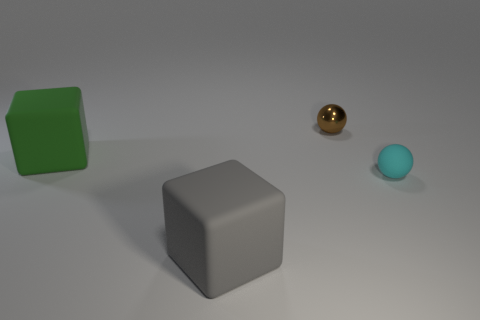Subtract all yellow spheres. Subtract all yellow cubes. How many spheres are left? 2 Add 4 large cyan objects. How many objects exist? 8 Subtract 1 brown balls. How many objects are left? 3 Subtract all purple metallic cylinders. Subtract all rubber balls. How many objects are left? 3 Add 1 brown shiny spheres. How many brown shiny spheres are left? 2 Add 1 small cyan matte objects. How many small cyan matte objects exist? 2 